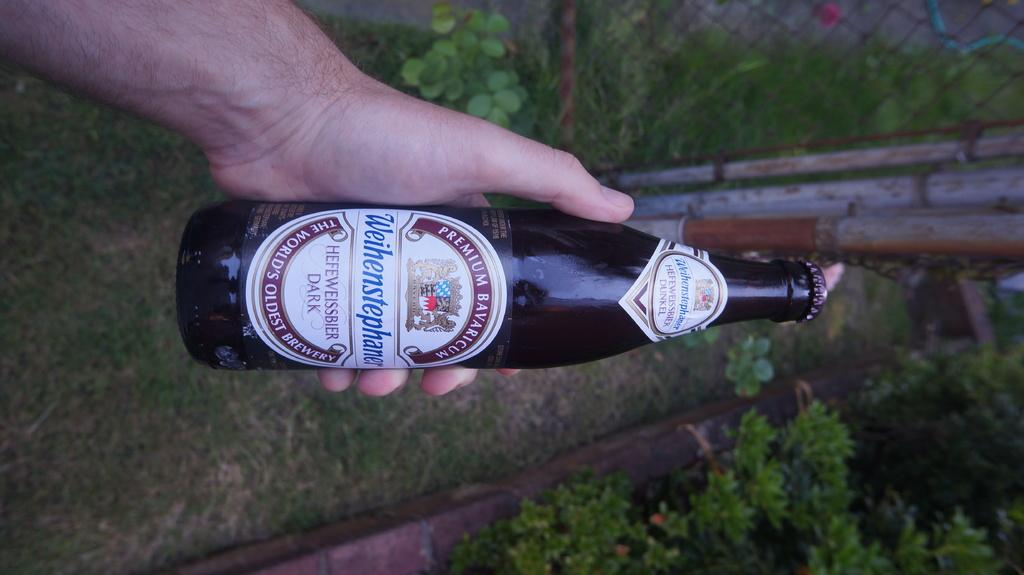<image>
Create a compact narrative representing the image presented. A bottle of Premium Bavaricum beer is being held sideways with it's cap on. 